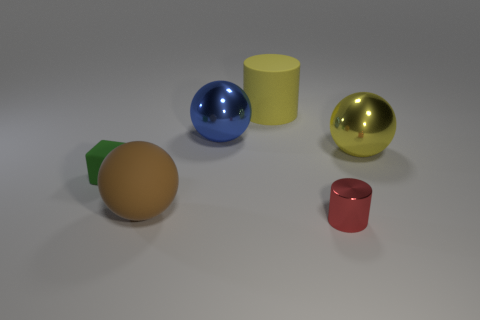Is the green block made of the same material as the big blue ball?
Offer a terse response. No. There is a thing that is on the left side of the blue shiny ball and on the right side of the small green rubber thing; what is its material?
Make the answer very short. Rubber. How many blocks are blue things or tiny matte objects?
Your answer should be very brief. 1. There is a large brown object that is the same shape as the blue shiny thing; what is its material?
Give a very brief answer. Rubber. What size is the red cylinder that is the same material as the big yellow ball?
Offer a very short reply. Small. Is the shape of the red shiny object in front of the big yellow ball the same as the large rubber object that is behind the small green thing?
Provide a succinct answer. Yes. There is a big ball that is made of the same material as the cube; what is its color?
Keep it short and to the point. Brown. There is a shiny ball in front of the blue sphere; does it have the same size as the rubber thing that is in front of the small rubber cube?
Offer a very short reply. Yes. The thing that is in front of the block and on the right side of the brown object has what shape?
Your answer should be compact. Cylinder. Is there a large sphere that has the same material as the red cylinder?
Keep it short and to the point. Yes. 